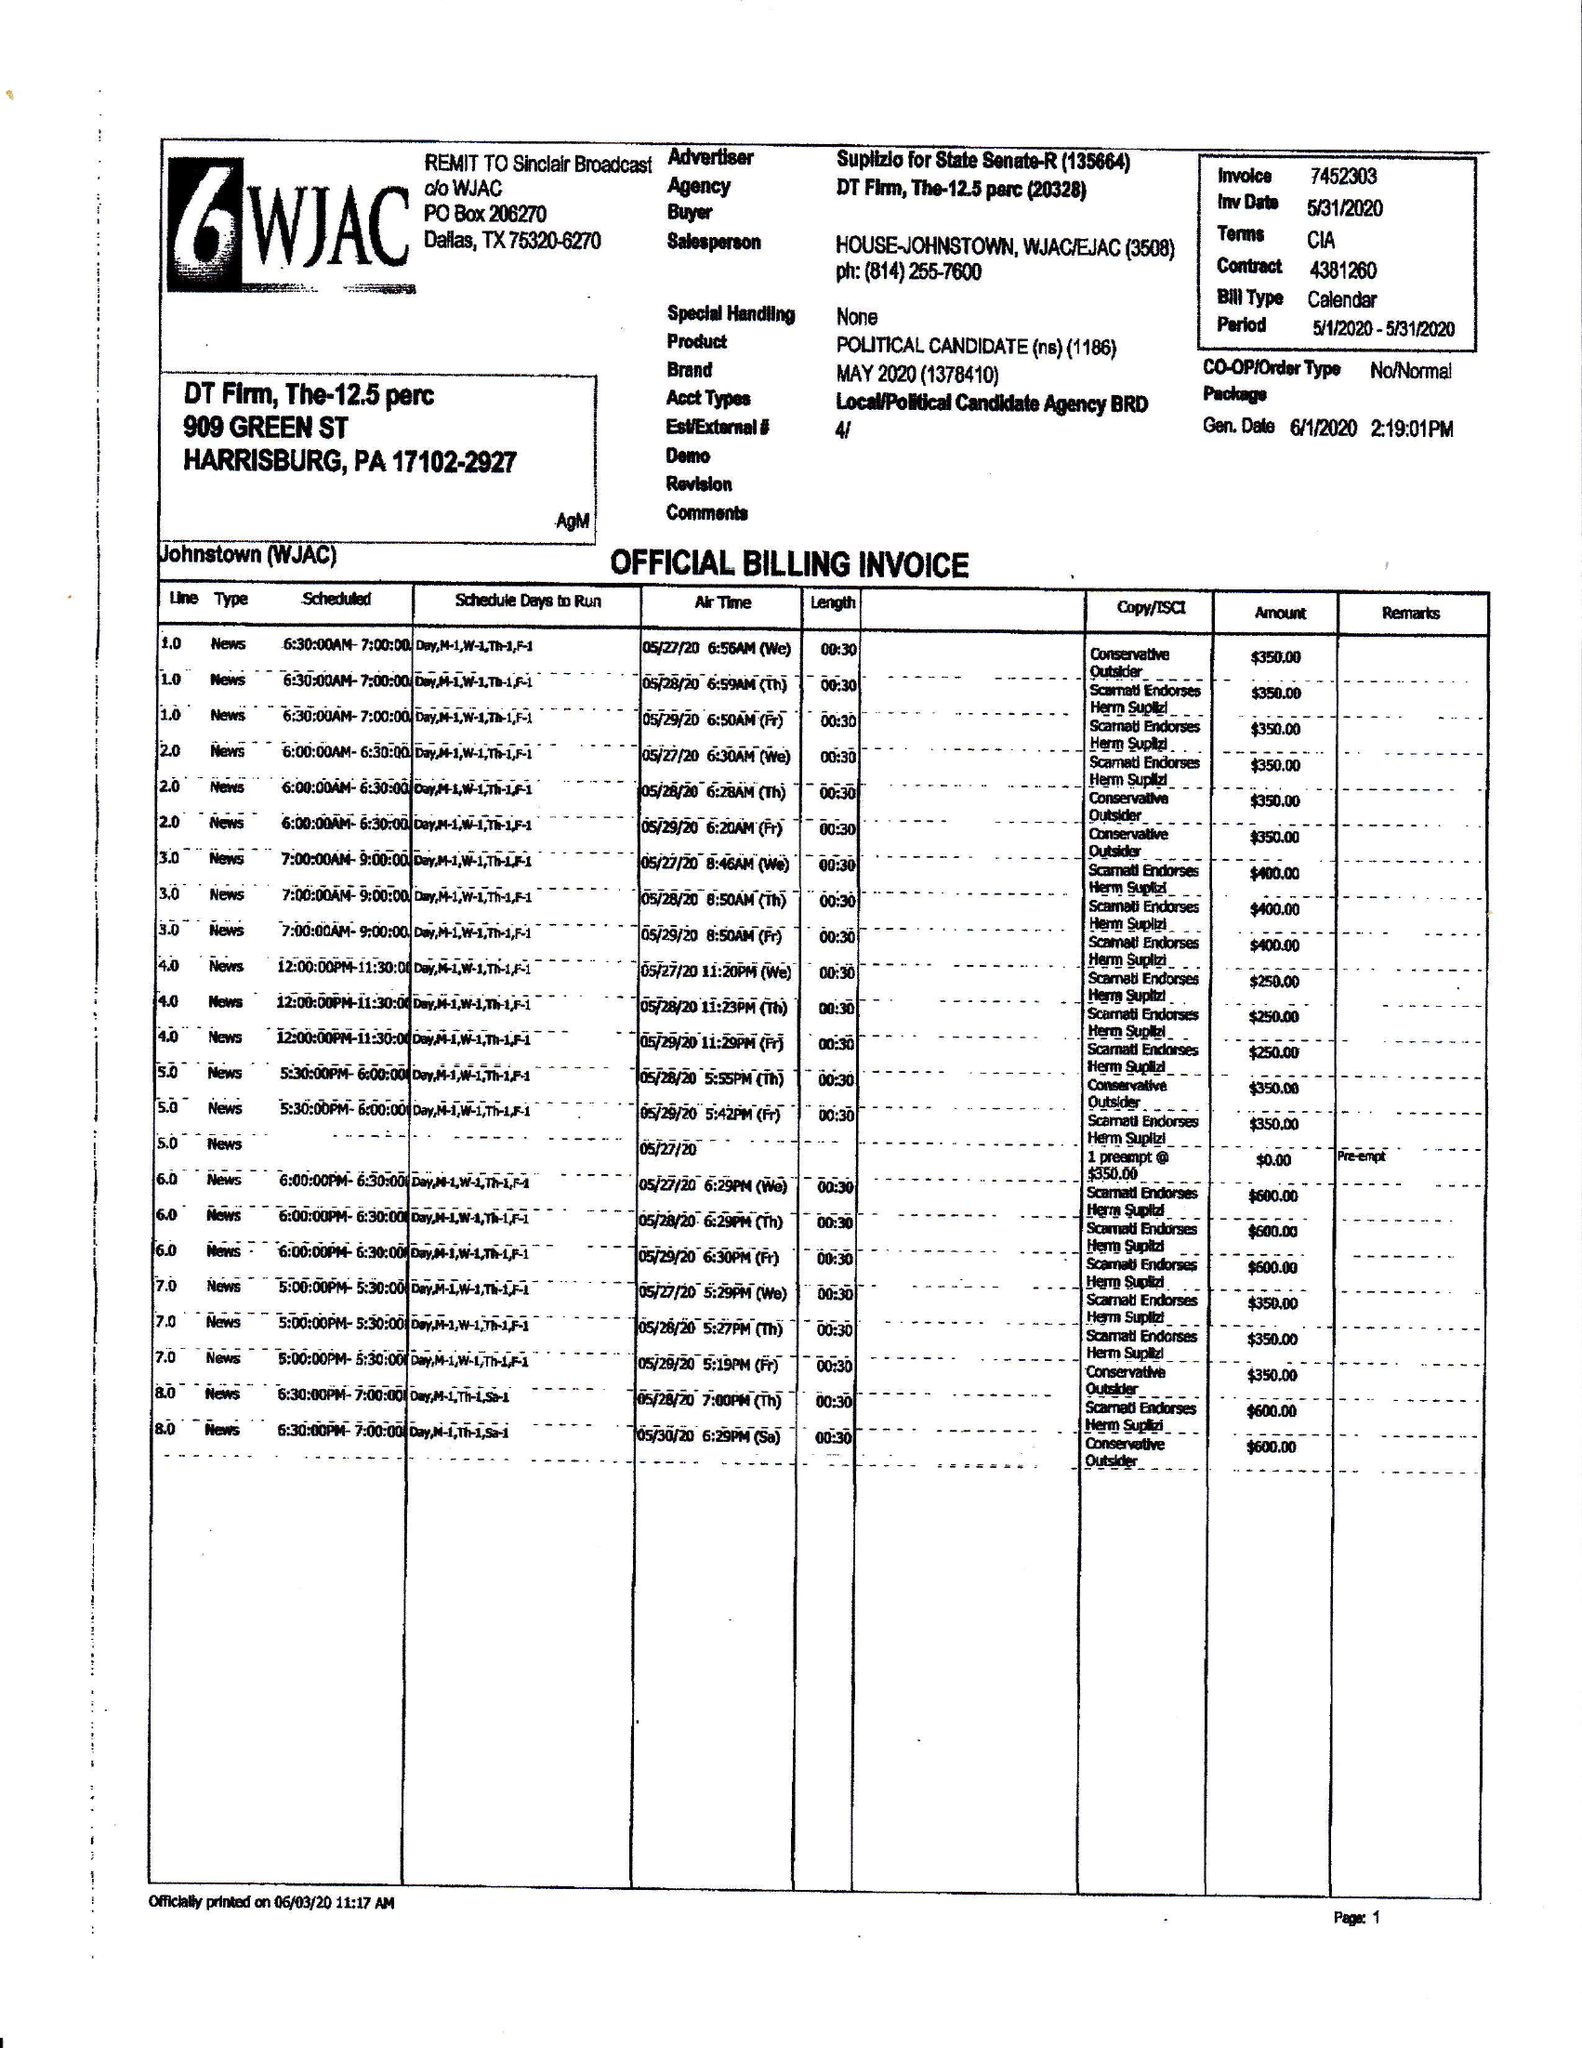What is the value for the flight_to?
Answer the question using a single word or phrase. 05/31/20 